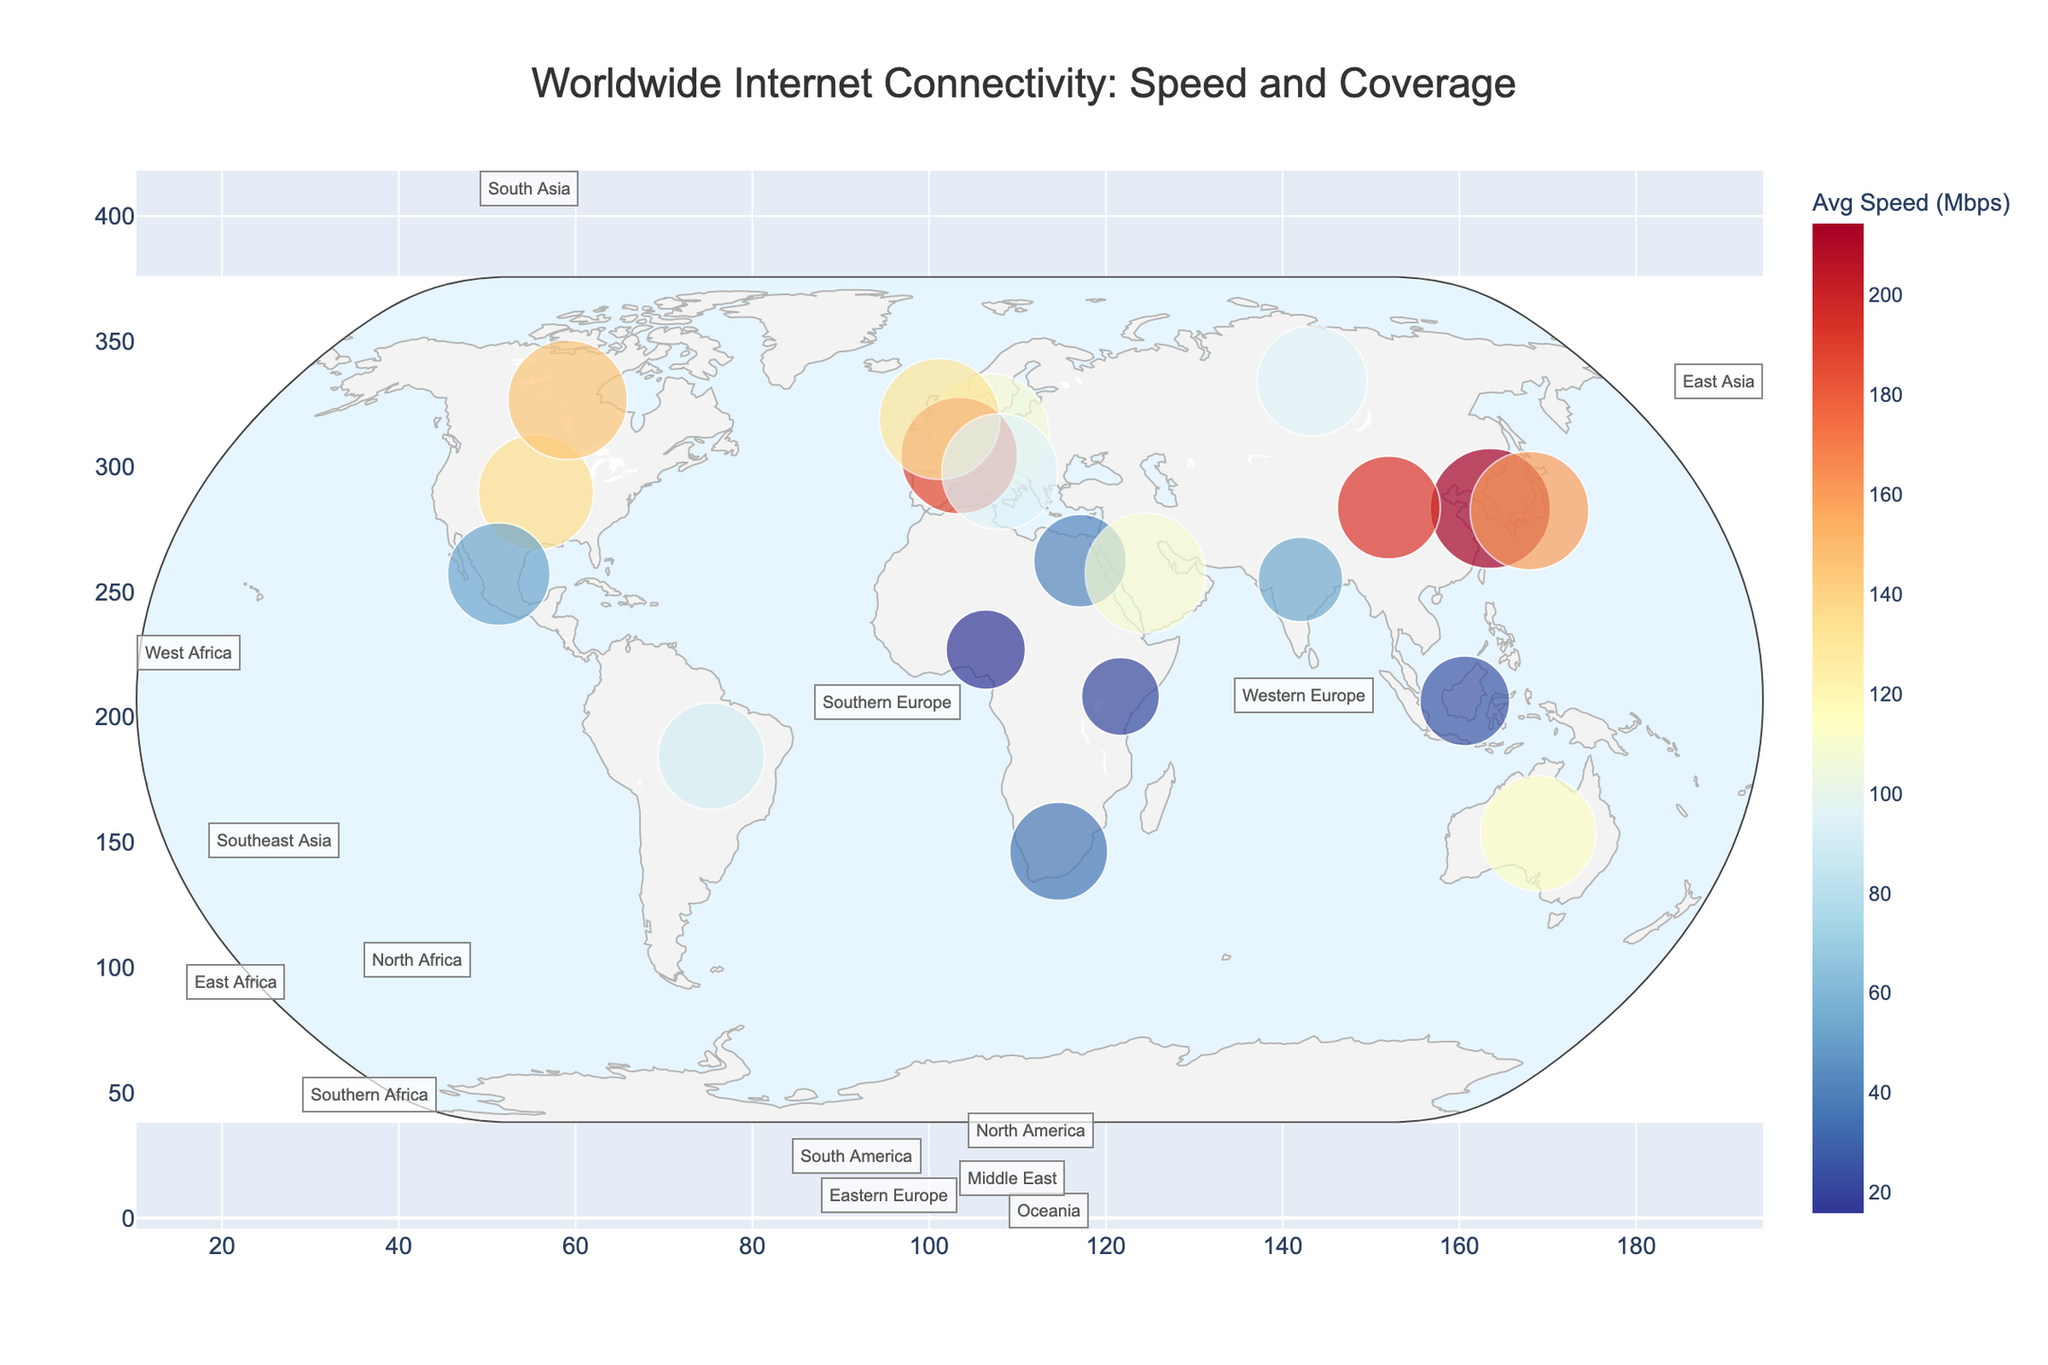What's the title of the figure? The title is located at the top center of the figure, which often summarizes the main idea.
Answer: Worldwide Internet Connectivity: Speed and Coverage Which country has the highest average internet speed? Look for the color representing the highest value in the color scale and identify the corresponding country label.
Answer: South Korea What's the average internet speed in Japan? Hovering over Japan, we can see the average internet speed mentioned in the hover data.
Answer: 159.87 Mbps Which region has the smallest coverage percentage in the figure? By examining the circle sizes and referring to the hover information, we identify the smallest circles and their regions.
Answer: East Africa (Kenya) Which countries in the North America region are shown in the figure? Identify the countries labeled within North America from the hover information or map location.
Answer: United States, Canada, Mexico What’s the average internet speed of countries in Western Europe? Add the average speeds of countries belonging to Western Europe and divide by their count.
Answer: (107.73 + 187.95 + 131.25)/(3) = 142.31 Mbps Which country has the highest population density and what is its average internet speed? Look for the hover data that lists population density, identify the highest, and cross-reference with average internet speed.
Answer: India, 54.73 Mbps Compare the internet coverage in East Asia and South Asia regions. Which has better coverage? Review the circles representing East Asia and South Asia countries and compare their sizes for coverage percentages.
Answer: East Asia How does the average internet speed in Eastern Europe compare to that in Western Europe? Check the average speeds from the hover info and compare Russia’s East Europe average with values from West Europe.
Answer: Western Europe's average speed is higher Which country has a larger population density but a lower average internet speed compared to South Korea? Find a country with higher population density than 503 and lower internet speed than 214.47 Mbps.
Answer: Japan 